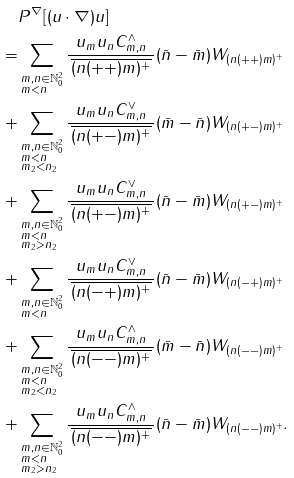Convert formula to latex. <formula><loc_0><loc_0><loc_500><loc_500>& P ^ { \nabla } [ ( u \cdot \nabla ) u ] \\ = & \sum _ { \begin{subarray} { l } m , n \in \mathbb { N } _ { 0 } ^ { 2 } \\ m < n \end{subarray} } \frac { u _ { m } u _ { n } C _ { m , n } ^ { \wedge } } { \, \overline { ( n ( + + ) m ) ^ { + } } \, } ( \bar { n } - \bar { m } ) W _ { ( n ( + + ) m ) ^ { + } } \\ + & \sum _ { \begin{subarray} { l } m , n \in \mathbb { N } _ { 0 } ^ { 2 } \\ m < n \\ m _ { 2 } < n _ { 2 } \end{subarray} } \frac { u _ { m } u _ { n } C _ { m , n } ^ { \vee } } { \, \overline { ( n ( + - ) m ) ^ { + } } \, } ( \bar { m } - \bar { n } ) W _ { ( n ( + - ) m ) ^ { + } } \\ + & \sum _ { \begin{subarray} { l } m , n \in \mathbb { N } _ { 0 } ^ { 2 } \\ m < n \\ m _ { 2 } > n _ { 2 } \end{subarray} } \frac { u _ { m } u _ { n } C _ { m , n } ^ { \vee } } { \, \overline { ( n ( + - ) m ) ^ { + } } \, } ( \bar { n } - \bar { m } ) W _ { ( n ( + - ) m ) ^ { + } } \\ + & \sum _ { \begin{subarray} { l } m , n \in \mathbb { N } _ { 0 } ^ { 2 } \\ m < n \end{subarray} } \frac { u _ { m } u _ { n } C _ { m , n } ^ { \vee } } { \, \overline { ( n ( - + ) m ) ^ { + } } \, } ( \bar { n } - \bar { m } ) W _ { ( n ( - + ) m ) ^ { + } } \\ + & \sum _ { \begin{subarray} { l } m , n \in \mathbb { N } _ { 0 } ^ { 2 } \\ m < n \\ m _ { 2 } < n _ { 2 } \end{subarray} } \frac { u _ { m } u _ { n } C _ { m , n } ^ { \wedge } } { \, \overline { ( n ( - - ) m ) ^ { + } } \, } ( \bar { m } - \bar { n } ) W _ { ( n ( - - ) m ) ^ { + } } \\ + & \sum _ { \begin{subarray} { l } m , n \in \mathbb { N } _ { 0 } ^ { 2 } \\ m < n \\ m _ { 2 } > n _ { 2 } \end{subarray} } \frac { u _ { m } u _ { n } C _ { m , n } ^ { \wedge } } { \, \overline { ( n ( - - ) m ) ^ { + } } \, } ( \bar { n } - \bar { m } ) W _ { ( n ( - - ) m ) ^ { + } } .</formula> 